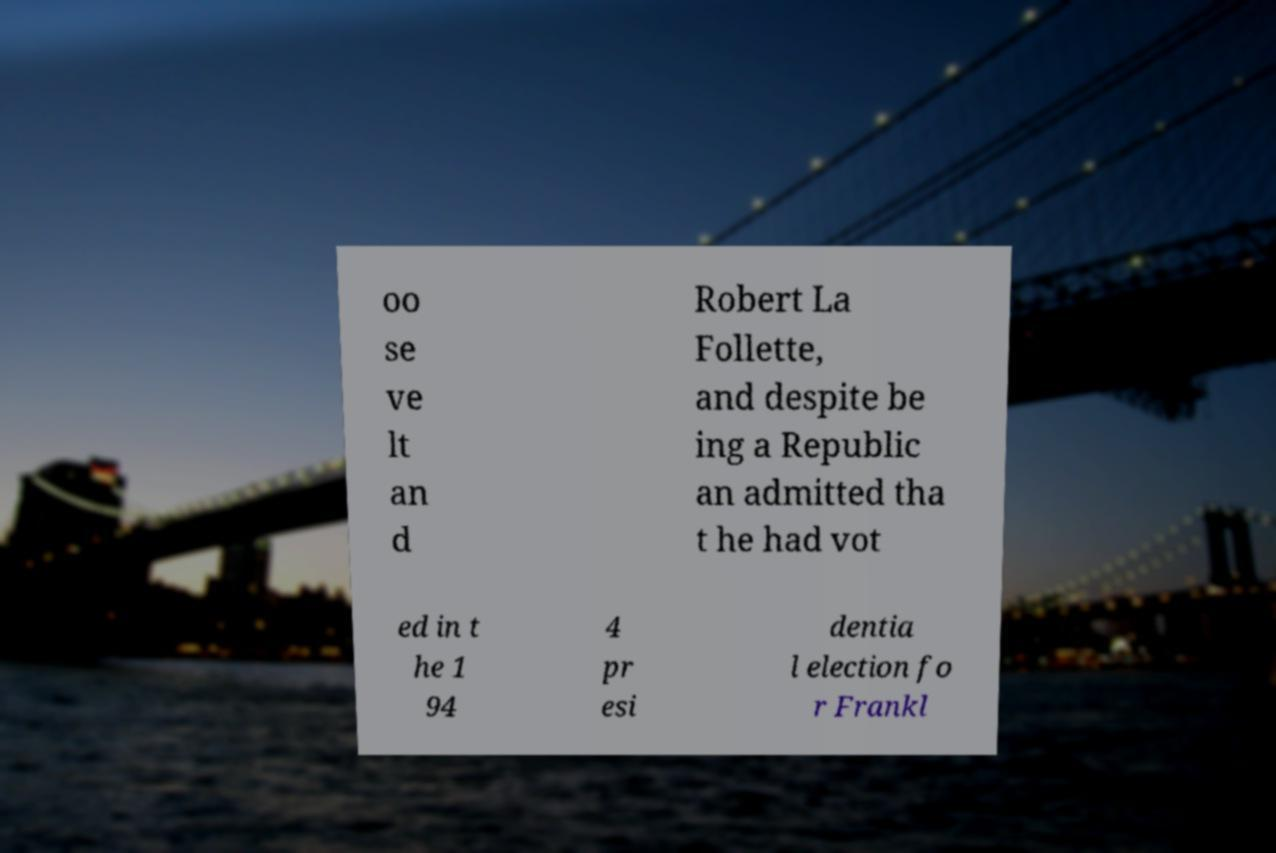There's text embedded in this image that I need extracted. Can you transcribe it verbatim? oo se ve lt an d Robert La Follette, and despite be ing a Republic an admitted tha t he had vot ed in t he 1 94 4 pr esi dentia l election fo r Frankl 